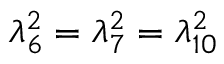<formula> <loc_0><loc_0><loc_500><loc_500>\lambda _ { 6 } ^ { 2 } = \lambda _ { 7 } ^ { 2 } = \lambda _ { 1 0 } ^ { 2 }</formula> 